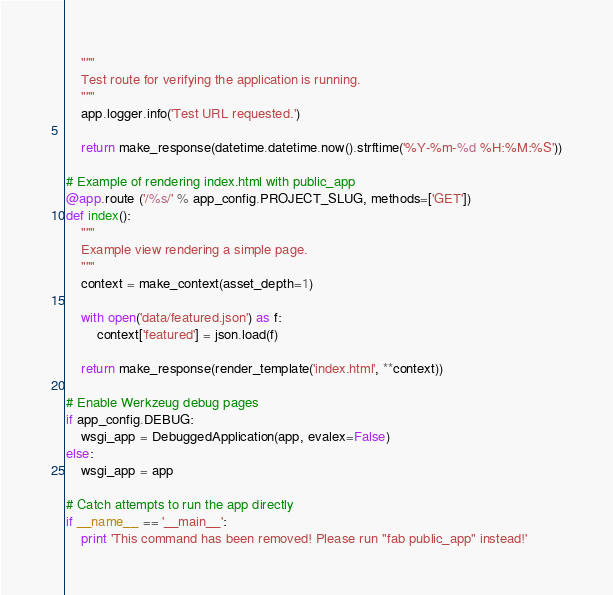<code> <loc_0><loc_0><loc_500><loc_500><_Python_>    """
    Test route for verifying the application is running.
    """
    app.logger.info('Test URL requested.')

    return make_response(datetime.datetime.now().strftime('%Y-%m-%d %H:%M:%S'))

# Example of rendering index.html with public_app 
@app.route ('/%s/' % app_config.PROJECT_SLUG, methods=['GET'])
def index():
    """
    Example view rendering a simple page.
    """
    context = make_context(asset_depth=1)

    with open('data/featured.json') as f:
        context['featured'] = json.load(f)

    return make_response(render_template('index.html', **context))

# Enable Werkzeug debug pages
if app_config.DEBUG:
    wsgi_app = DebuggedApplication(app, evalex=False)
else:
    wsgi_app = app

# Catch attempts to run the app directly
if __name__ == '__main__':
    print 'This command has been removed! Please run "fab public_app" instead!'
</code> 